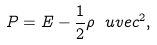Convert formula to latex. <formula><loc_0><loc_0><loc_500><loc_500>P = E - \frac { 1 } { 2 } \rho \ u v e c ^ { 2 } ,</formula> 